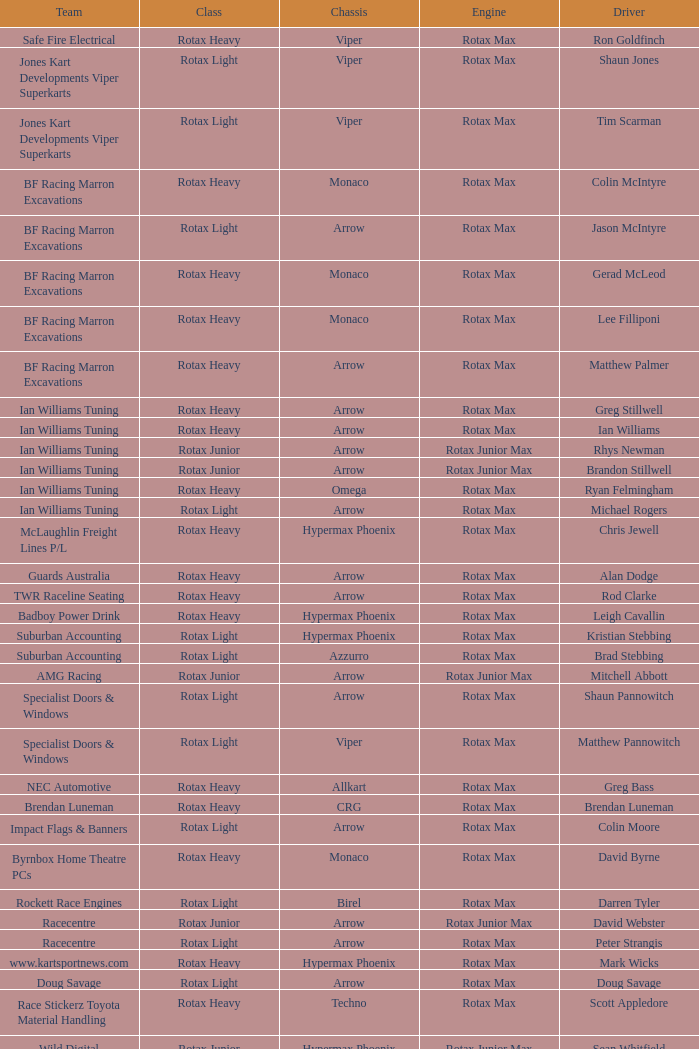In the rotax light category, what is the name of the team? Jones Kart Developments Viper Superkarts, Jones Kart Developments Viper Superkarts, BF Racing Marron Excavations, Ian Williams Tuning, Suburban Accounting, Suburban Accounting, Specialist Doors & Windows, Specialist Doors & Windows, Impact Flags & Banners, Rockett Race Engines, Racecentre, Doug Savage. 